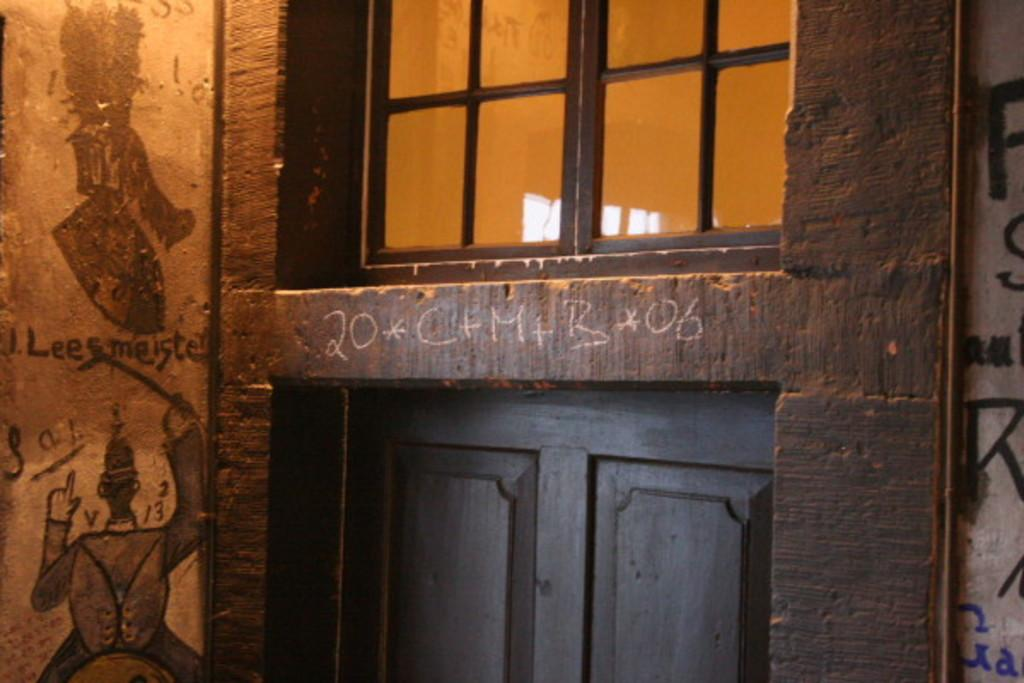What type of opening can be seen in the image? There is a window in the image. What is located beneath the window? There is a door under the window. What decorative elements are present on the left side of the image? There are paintings on the wall on the left side of the image. What type of trade is being conducted in the image? There is no indication of any trade taking place in the image. Are there any mittens visible in the image? There are no mittens present in the image. 